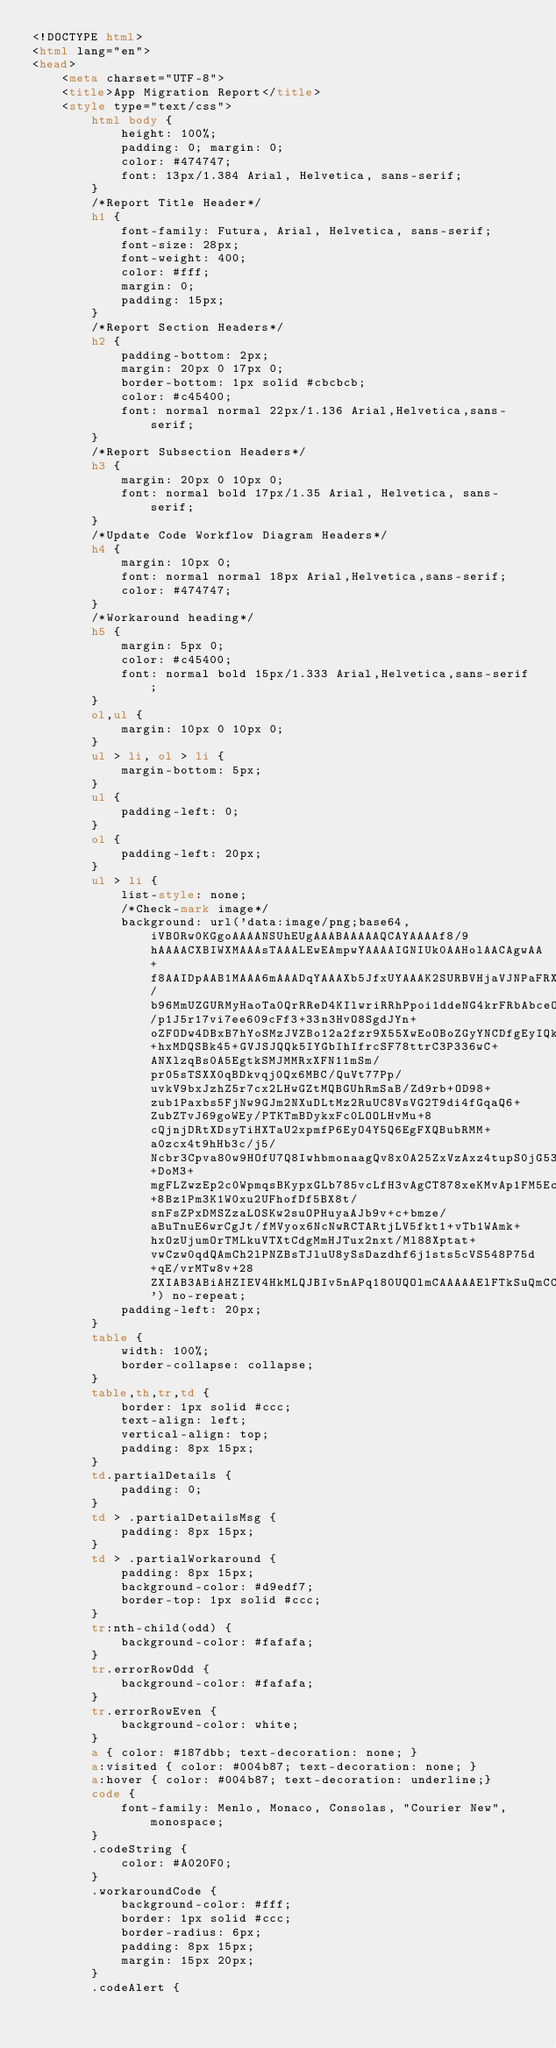Convert code to text. <code><loc_0><loc_0><loc_500><loc_500><_HTML_><!DOCTYPE html>
<html lang="en">
<head>
    <meta charset="UTF-8">
    <title>App Migration Report</title>
    <style type="text/css">
        html body {
            height: 100%;
            padding: 0; margin: 0;
            color: #474747;
            font: 13px/1.384 Arial, Helvetica, sans-serif;
        }
        /*Report Title Header*/
        h1 {
            font-family: Futura, Arial, Helvetica, sans-serif;
            font-size: 28px;
            font-weight: 400;
            color: #fff;
            margin: 0;
            padding: 15px;
        }
        /*Report Section Headers*/
        h2 {
            padding-bottom: 2px;
            margin: 20px 0 17px 0;
            border-bottom: 1px solid #cbcbcb;
            color: #c45400;
            font: normal normal 22px/1.136 Arial,Helvetica,sans-serif;
        }
        /*Report Subsection Headers*/
        h3 {
            margin: 20px 0 10px 0;
            font: normal bold 17px/1.35 Arial, Helvetica, sans-serif;
        }
        /*Update Code Workflow Diagram Headers*/
        h4 {
            margin: 10px 0;
            font: normal normal 18px Arial,Helvetica,sans-serif;
            color: #474747;
        }
        /*Workaround heading*/
        h5 {
            margin: 5px 0;
            color: #c45400;
            font: normal bold 15px/1.333 Arial,Helvetica,sans-serif;
        }
        ol,ul {
            margin: 10px 0 10px 0;
        }
        ul > li, ol > li {
            margin-bottom: 5px;
        }
        ul {
            padding-left: 0;
        }
        ol {
            padding-left: 20px;
        }
        ul > li {
            list-style: none;
            /*Check-mark image*/
            background: url('data:image/png;base64,iVBORw0KGgoAAAANSUhEUgAAABAAAAAQCAYAAAAf8/9hAAAACXBIWXMAAAsTAAALEwEAmpwYAAAAIGNIUk0AAHolAACAgwAA+f8AAIDpAAB1MAAA6mAAADqYAAAXb5JfxUYAAAK2SURBVHjaVJNPaFRXFMZ/b96MmUZGURMyHaoTa0QrRReD4KIlwriRRhPpoi1ddeNG4krFRbAbceOf0qJuSoWWWlooIiKlCSkp1ARksEmpi8GSQjKJUSYk/p1J5r17vi7ee609cFf3+33n3HvO8SgdJYn+oZFODw4DBxB7hYoSMzJVZBo12a2fzr9X55XwEoOBoZGyYNCDfgEyIQkMzIRkBKupYXN89svVg8OJgU+hxMDQSBk45+GVJSJQQk5IYGbIhIfrcSF78ttrC3P336wC+ANXlzqBs0A5EgtkSMJMMRxXFN11mSm/pr05sTSXX0qBDkvqj0Qx6MBC/QuVt77Pp/uvkV9bxJzhZ5r7cx2LHwGZtMQBGUhRmSaB/Zd9rb+OD98+zub1Paxbs5FjNw9GJm2NXuDLtMz2RuUC8VsVG2T9di4fGqaQ6+ZubZTvJ69goWEy/PTKTmBDykxFc0LOOLHvMu+8cQjnjDRtXDsyTiHXTaU2xpmfP6EyO4Y5Q6EgFXQBubRMM+a0zcx4t9hHb3c/j5/Ncbr3Cpva80w9HOfU7Q8IwhbmonaagQv8x0A25ZxVzAxz4tupS0jG5323eT1XZHL+DoM3+mgFLZwzEp2c0WpmqsBKypxGLb785vcLfH3vAgCT878xeKMvAp1FM5Ecg5Wn6+8Bz1Pm3K1W0xu2UFhofDf5BX8t/snFsZPxDMSZzaLOSKw2suOPHuyaAJb9v+c+bmze/aBuTnuE6wrCgJt/fMVyox6NcNwRCTARtjLV5fkt1+vTb1WAmk+hxOzUjumOrTMLkuVTXtCdgMmHJTux2nxt/Ml88Xptat+vwCzw0qdQAmCh2lPNZBsTJluU8ySsDazdhf6j1sts5cVS548P75d+qE/vrMTw8v+28ZXIAB3ABiAHZIEV4HkMLQJBIv5nAPq180UQOlmCAAAAAElFTkSuQmCC') no-repeat;
            padding-left: 20px;
        }
        table {
            width: 100%;
            border-collapse: collapse;
        }
        table,th,tr,td {
            border: 1px solid #ccc;
            text-align: left;
            vertical-align: top;
            padding: 8px 15px;
        }
        td.partialDetails {
            padding: 0;
        }
        td > .partialDetailsMsg {
            padding: 8px 15px;
        }
        td > .partialWorkaround {
            padding: 8px 15px;
            background-color: #d9edf7;
            border-top: 1px solid #ccc;
        }
        tr:nth-child(odd) {
            background-color: #fafafa;
        }
        tr.errorRowOdd {
            background-color: #fafafa;
        }
        tr.errorRowEven {
            background-color: white;
        }
        a { color: #187dbb; text-decoration: none; }
        a:visited { color: #004b87; text-decoration: none; }
        a:hover { color: #004b87; text-decoration: underline;}
        code {
            font-family: Menlo, Monaco, Consolas, "Courier New", monospace;
        }
        .codeString {
            color: #A020F0;
        }
        .workaroundCode {
            background-color: #fff;
            border: 1px solid #ccc;
            border-radius: 6px;
            padding: 8px 15px;
            margin: 15px 20px;
        }
        .codeAlert {</code> 